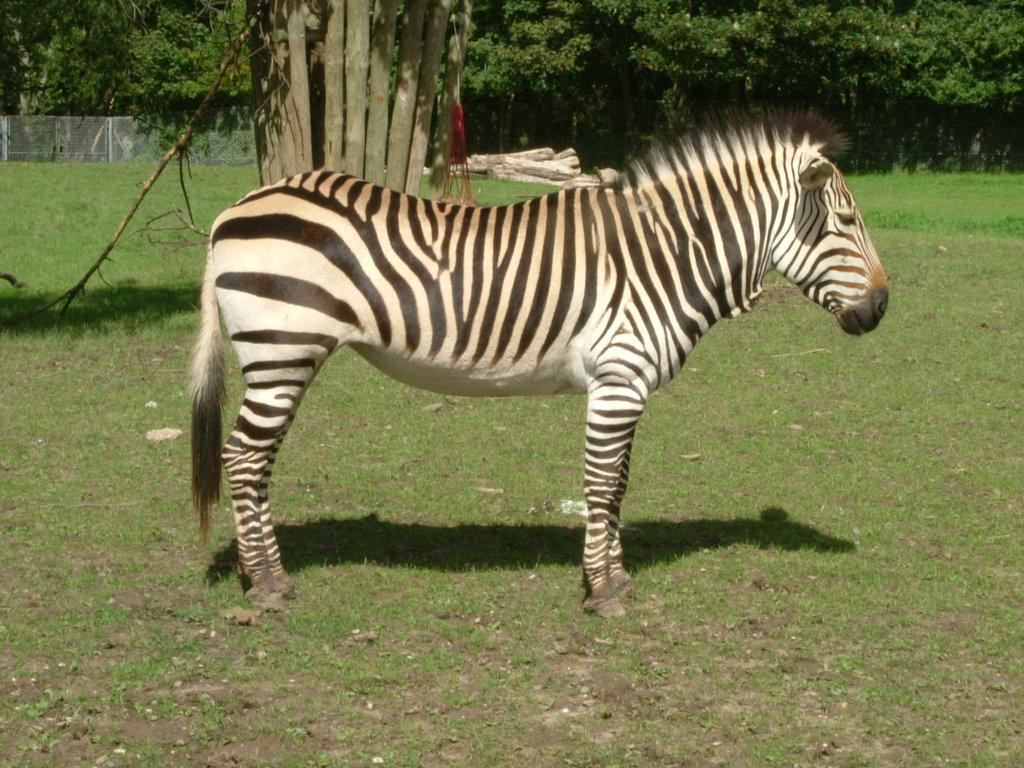What animal is present in the image? There is a zebra in the image. What is the zebra doing in the image? The zebra is standing on the ground. What can be seen in the background of the image? There are trees, a fence, and wooden sticks in the background of the image. What type of offer is the zebra making to the bike in the image? There is no bike present in the image, so the zebra cannot be making any offer to a bike. 